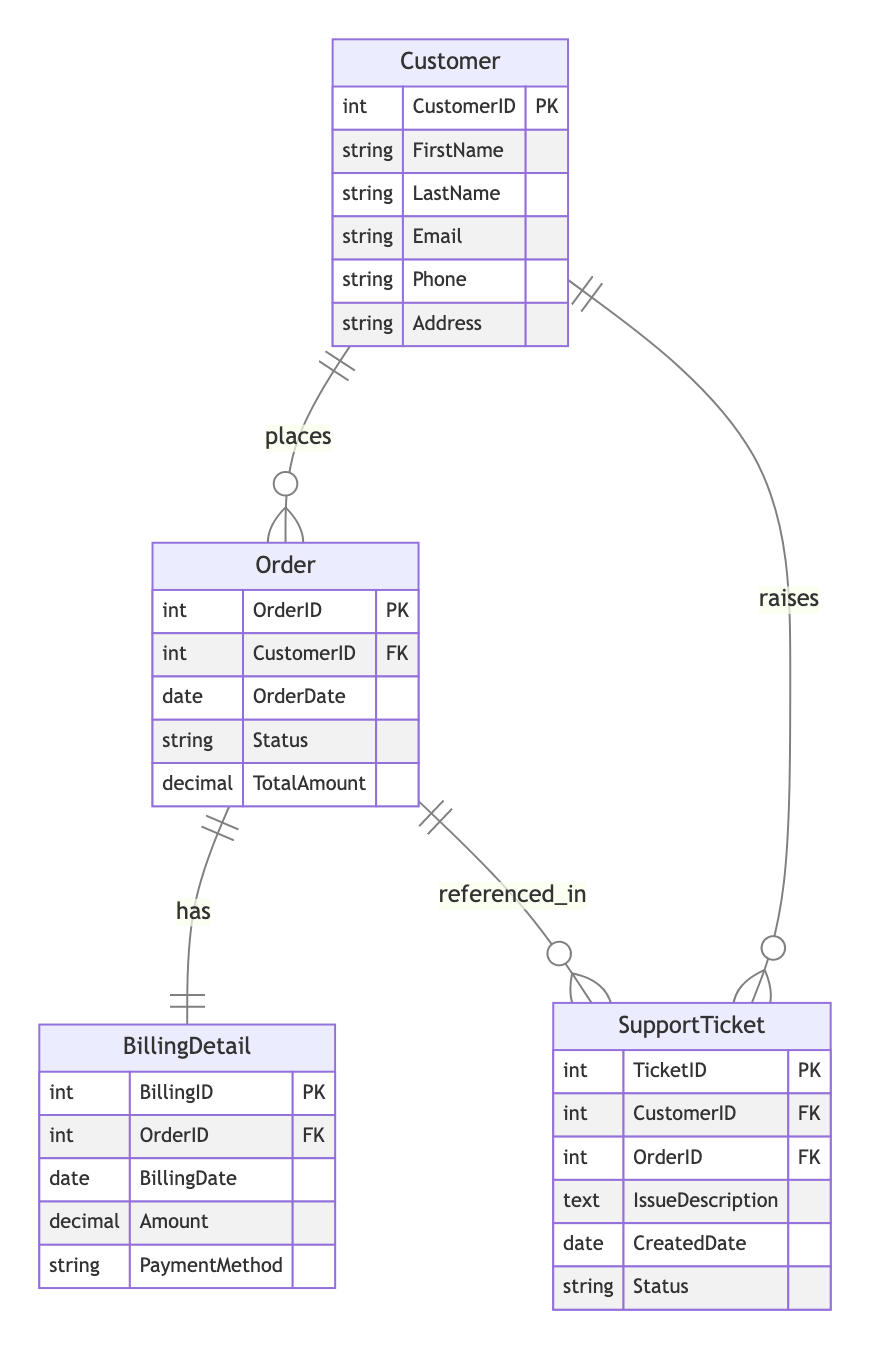What is the primary key of the Customer entity? In the diagram, the attributes of the Customer entity are listed, and it specifies that the CustomerID is marked as the Primary Key (PK). Therefore, the answer is drawn directly from this identification in the entity.
Answer: CustomerID What is the cardinality between Customer and Order? The cardinality relationship depicted between the Customer and Order entities is "1:n," indicating that a single customer can have multiple orders. This is visible clearly in the relationship label under the association line connecting the two entities.
Answer: 1:n How many attributes does the BillingDetail entity have? The BillingDetail entity lists its attributes directly in the diagram. It has five attributes: BillingID, OrderID, BillingDate, Amount, and PaymentMethod. Counting these attributes provides the total.
Answer: 5 What relationship exists between Order and BillingDetail? The relationship depicted between the Order and BillingDetail entities is labeled as "has," indicating that each order has one associated billing detail. This can be noted by the association line with the label linking the two entities.
Answer: has How many foreign keys are present in the SupportTicket entity? In the SupportTicket entity, there are two references to other entities as foreign keys: CustomerID and OrderID. Evaluating the attributes section of the SupportTicket entity reveals this information, leading to the conclusion.
Answer: 2 Which entity can raise multiple support tickets? The Customer entity is indicated to have a one-to-many relationship (1:n) with the SupportTicket entity, suggesting that a customer can raise multiple support tickets. This relationship is noted in the diagram.
Answer: Customer What is the primary key of the Order entity? The Order entity’s attributes list OrderID as the Primary Key (PK). This information is explicitly stated in the entity’s definition in the diagram.
Answer: OrderID What is the maximum number of billing details an order can have? According to the relationship between Order and BillingDetail, which is labeled "1:1," this indicates that each order can have exactly one associated billing detail. Therefore, analyzing this single relation leads to the answer.
Answer: 1 In how many different entities does CustomerID appear? The CustomerID appears in three different entities: Customer, Order, and SupportTicket. By reviewing the references in these entities, one can count the appearances.
Answer: 3 